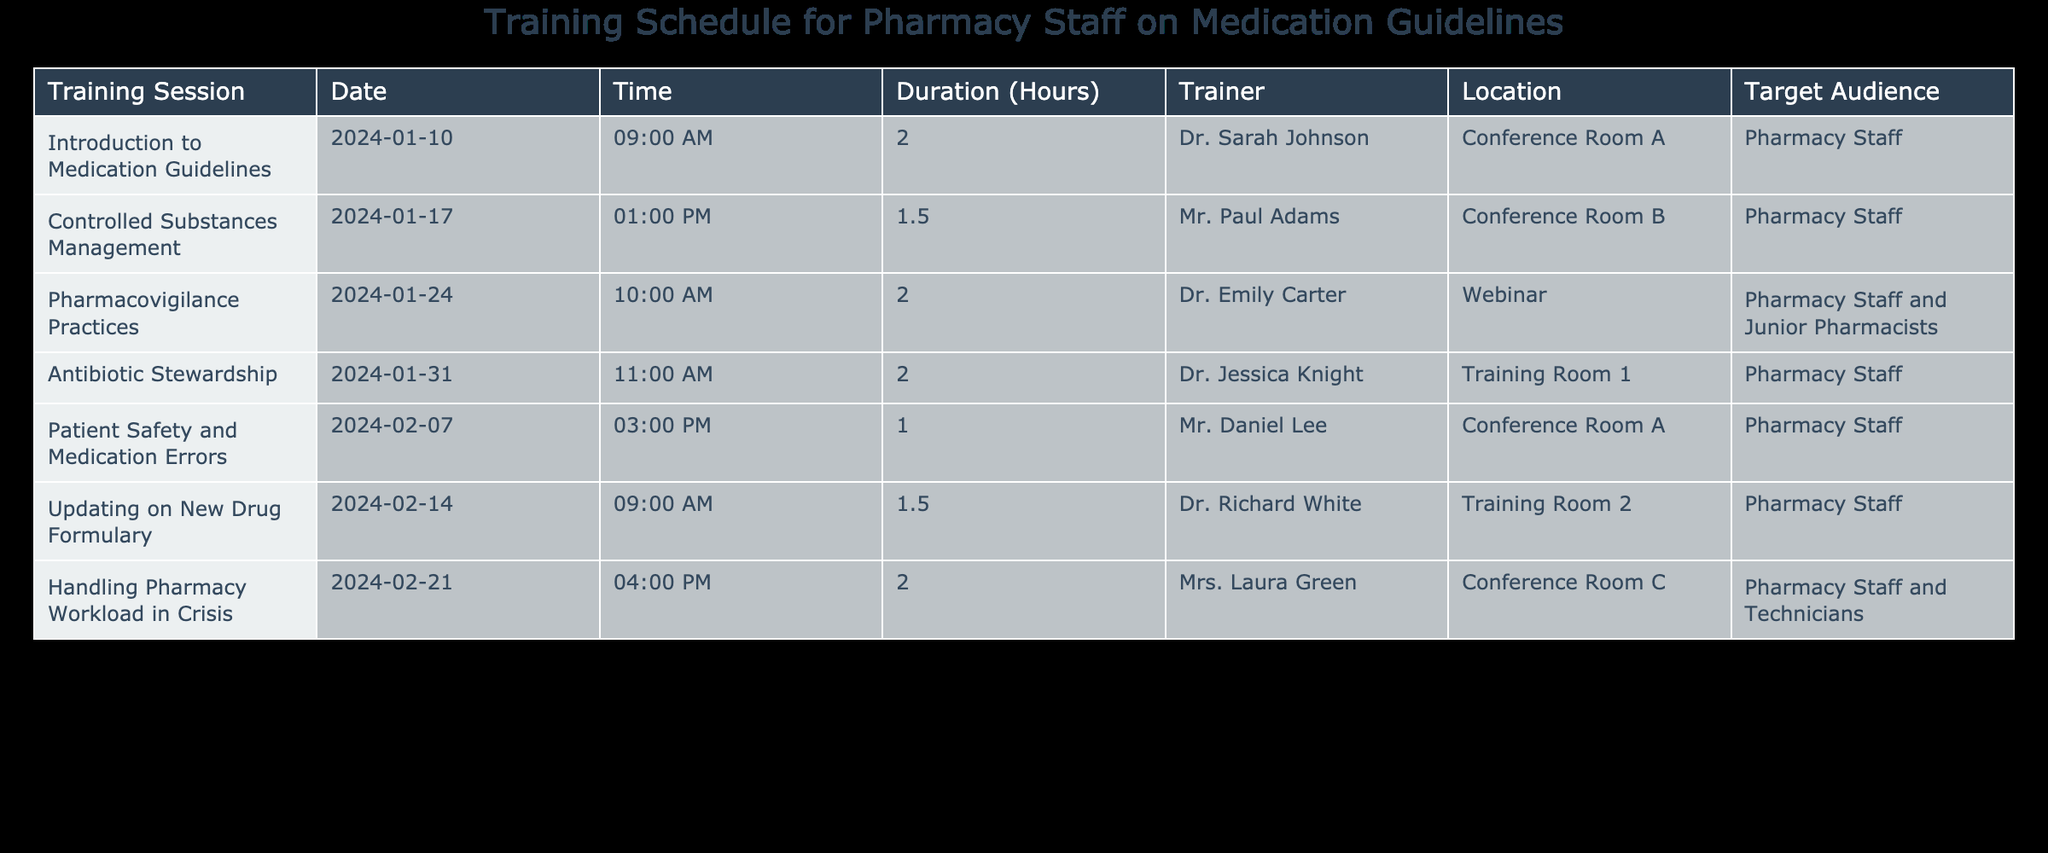What is the duration of the "Controlled Substances Management" training session? The table lists the "Controlled Substances Management" training session, and under the Duration (Hours) column, its value is 1.5.
Answer: 1.5 Who is the trainer for the "Patient Safety and Medication Errors" session? Looking at the table, the trainer listed for the session "Patient Safety and Medication Errors" is Mr. Daniel Lee.
Answer: Mr. Daniel Lee How many training sessions are scheduled for February 2024? By checking the Date column for February 2024, there are three sessions scheduled: "Patient Safety and Medication Errors," "Updating on New Drug Formulary," and "Handling Pharmacy Workload in Crisis."
Answer: 3 What is the average duration of the training sessions in January 2024? The training sessions in January are "Introduction to Medication Guidelines" (2 hours) and "Controlled Substances Management" (1.5 hours). Adding the durations gives 2 + 1.5 = 3.5 hours, and dividing by 2 (the number of sessions) gives an average of 3.5/2 = 1.75 hours.
Answer: 1.75 Is the "Pharmacovigilance Practices" training session conducted in-person? The table indicates that the "Pharmacovigilance Practices" session is a Webinar, which means it is not conducted in-person.
Answer: No What time does the "Updating on New Drug Formulary" session start? According to the table, the "Updating on New Drug Formulary" session is scheduled to start at 9:00 AM.
Answer: 9:00 AM Which training session has the longest duration? By analyzing the Duration (Hours) column, both the "Introduction to Medication Guidelines" and "Antibiotic Stewardship" sessions have a duration of 2 hours, which is the longest. Therefore, the longest duration is 2 hours.
Answer: 2 hours How many total hours of training are scheduled for all sessions combined? Adding all the durations together: 2 + 1.5 + 2 + 2 + 1 + 1.5 + 2 = 12 hours total for all sessions combined.
Answer: 12 hours When is the last training session scheduled? The table shows that the last training session is "Handling Pharmacy Workload in Crisis," scheduled for February 21, 2024.
Answer: February 21, 2024 